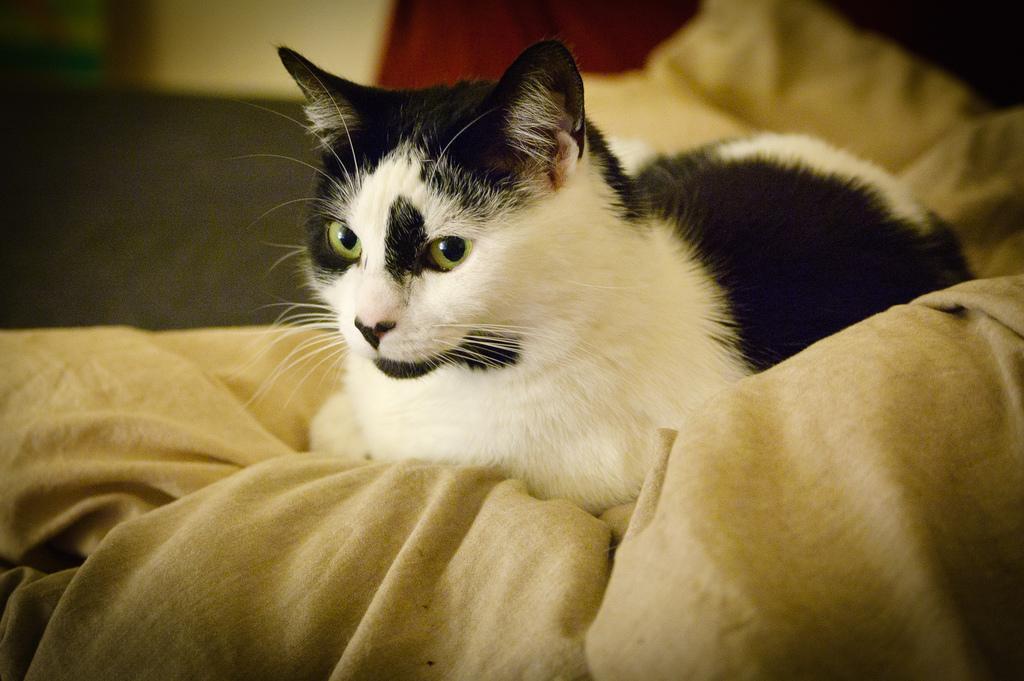How would you summarize this image in a sentence or two? In the picture I can see a cat which is in black and white color is sitting on the surface and the background of the image is blurred. 